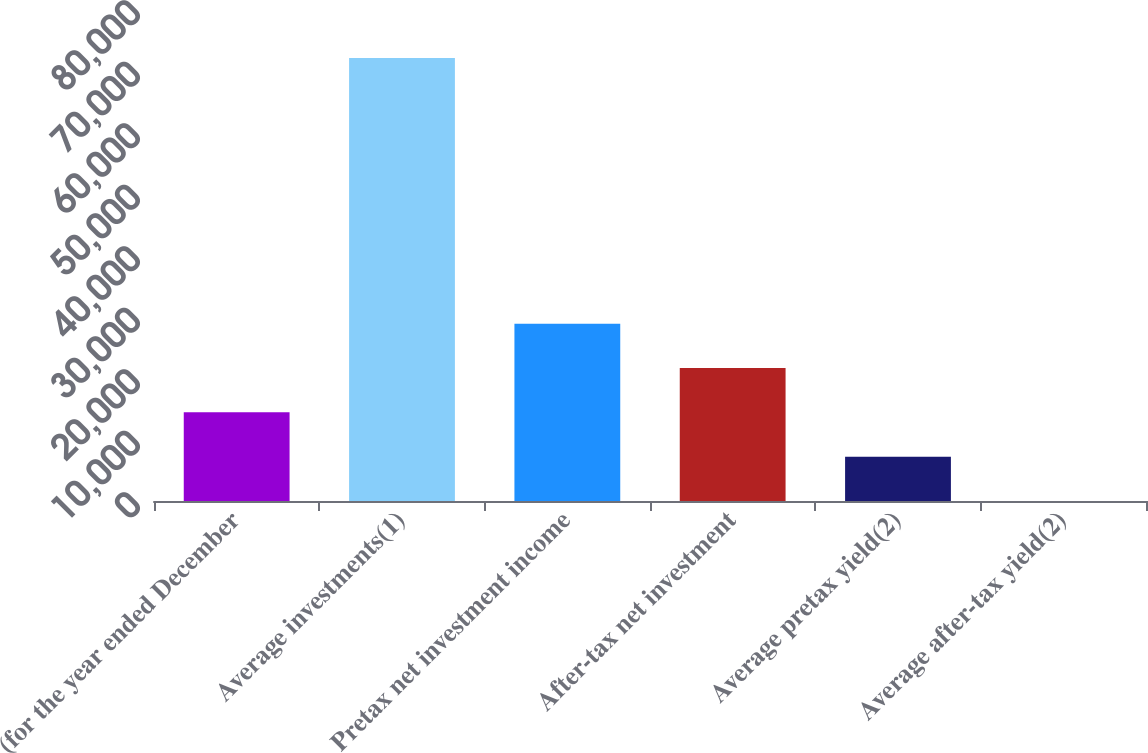Convert chart to OTSL. <chart><loc_0><loc_0><loc_500><loc_500><bar_chart><fcel>(for the year ended December<fcel>Average investments(1)<fcel>Pretax net investment income<fcel>After-tax net investment<fcel>Average pretax yield(2)<fcel>Average after-tax yield(2)<nl><fcel>14412.3<fcel>72049<fcel>28821.5<fcel>21616.9<fcel>7207.69<fcel>3.1<nl></chart> 